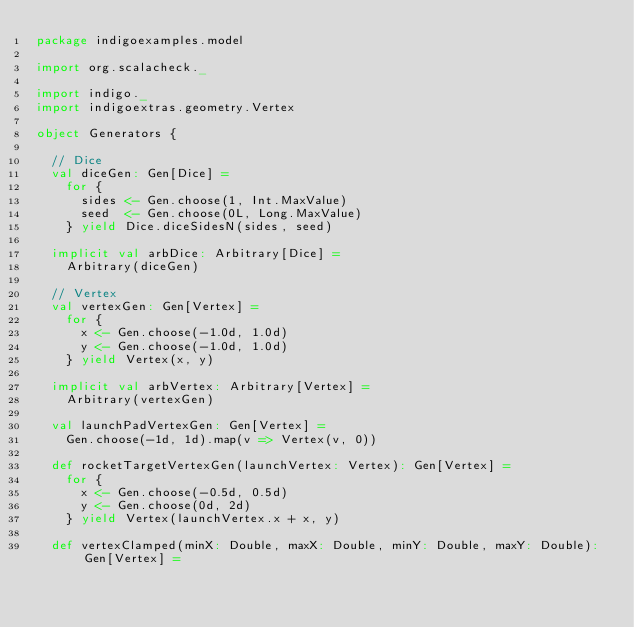Convert code to text. <code><loc_0><loc_0><loc_500><loc_500><_Scala_>package indigoexamples.model

import org.scalacheck._

import indigo._
import indigoextras.geometry.Vertex

object Generators {

  // Dice
  val diceGen: Gen[Dice] =
    for {
      sides <- Gen.choose(1, Int.MaxValue)
      seed  <- Gen.choose(0L, Long.MaxValue)
    } yield Dice.diceSidesN(sides, seed)

  implicit val arbDice: Arbitrary[Dice] =
    Arbitrary(diceGen)

  // Vertex
  val vertexGen: Gen[Vertex] =
    for {
      x <- Gen.choose(-1.0d, 1.0d)
      y <- Gen.choose(-1.0d, 1.0d)
    } yield Vertex(x, y)

  implicit val arbVertex: Arbitrary[Vertex] =
    Arbitrary(vertexGen)

  val launchPadVertexGen: Gen[Vertex] =
    Gen.choose(-1d, 1d).map(v => Vertex(v, 0))

  def rocketTargetVertexGen(launchVertex: Vertex): Gen[Vertex] =
    for {
      x <- Gen.choose(-0.5d, 0.5d)
      y <- Gen.choose(0d, 2d)
    } yield Vertex(launchVertex.x + x, y)

  def vertexClamped(minX: Double, maxX: Double, minY: Double, maxY: Double): Gen[Vertex] =</code> 